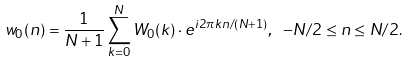<formula> <loc_0><loc_0><loc_500><loc_500>w _ { 0 } ( n ) = { \frac { 1 } { N + 1 } } \sum _ { k = 0 } ^ { N } W _ { 0 } ( k ) \cdot e ^ { i 2 \pi k n / ( N + 1 ) } , \ - N / 2 \leq n \leq N / 2 .</formula> 